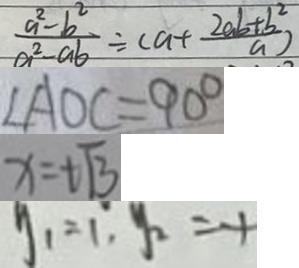Convert formula to latex. <formula><loc_0><loc_0><loc_500><loc_500>\frac { a ^ { 2 } - b ^ { 2 } } { a ^ { 2 } - a b } \div ( a + \frac { 2 a b + b ^ { 2 } } { a } ) 
 \angle A O C = 9 0 ^ { \circ } 
 x = t \sqrt { 3 } 
 y _ { 1 } = 1 , y _ { 2 } = - 1</formula> 